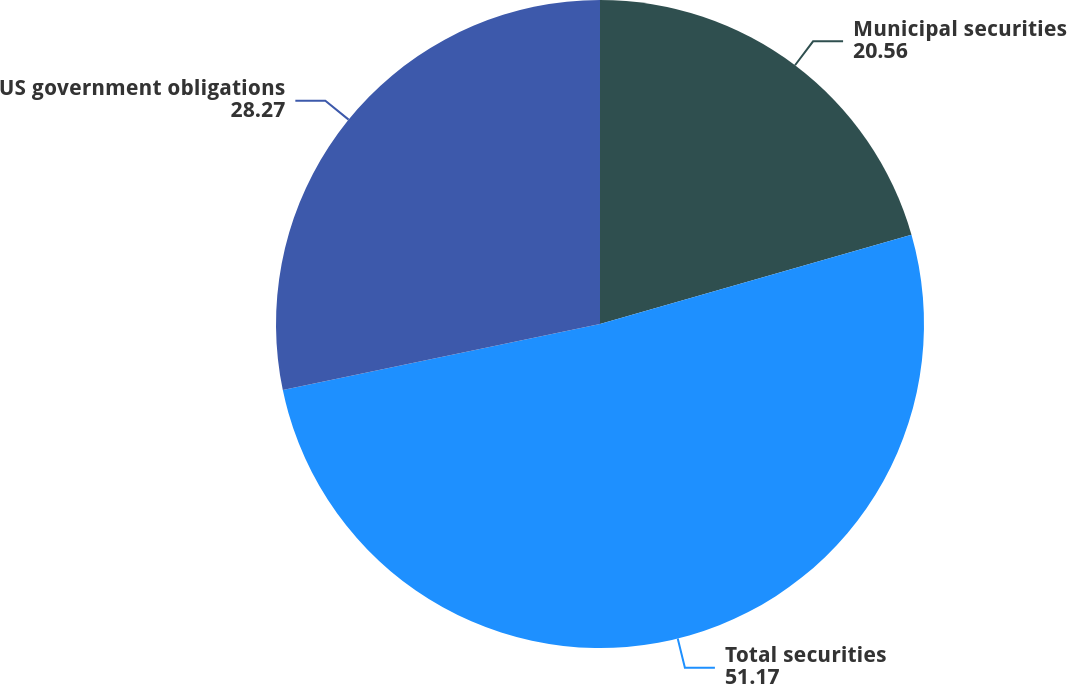Convert chart to OTSL. <chart><loc_0><loc_0><loc_500><loc_500><pie_chart><fcel>Municipal securities<fcel>Total securities<fcel>US government obligations<nl><fcel>20.56%<fcel>51.17%<fcel>28.27%<nl></chart> 